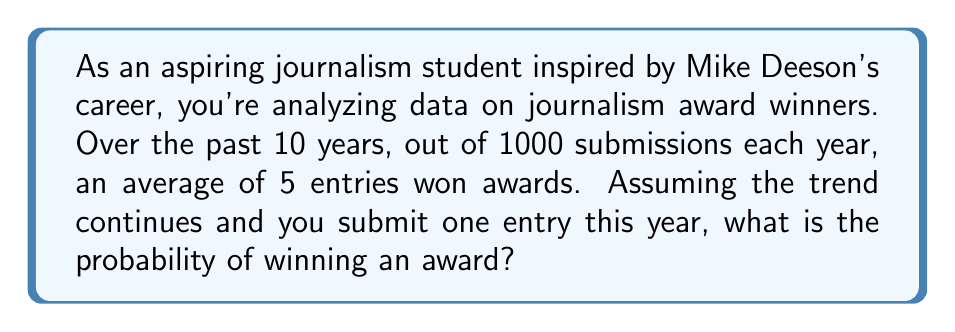Solve this math problem. Let's approach this step-by-step:

1) First, we need to calculate the probability of winning based on the given data:

   Average winners per year = 5
   Total submissions per year = 1000

2) The probability of winning can be calculated as:

   $P(\text{winning}) = \frac{\text{Number of winners}}{\text{Total submissions}}$

3) Substituting the values:

   $P(\text{winning}) = \frac{5}{1000} = 0.005$

4) This probability can also be expressed as a percentage:

   $0.005 \times 100\% = 0.5\%$

5) The question asks for the probability of winning with one submission. Since each submission is assumed to have an equal chance of winning, and you're submitting once, this calculated probability (0.005 or 0.5%) is your chance of winning.

6) In probability theory, this scenario follows a Bernoulli distribution, where:

   $P(X=1) = p$ and $P(X=0) = 1-p$

   Here, $p = 0.005$, representing the probability of success (winning).
Answer: $0.005$ or $0.5\%$ 